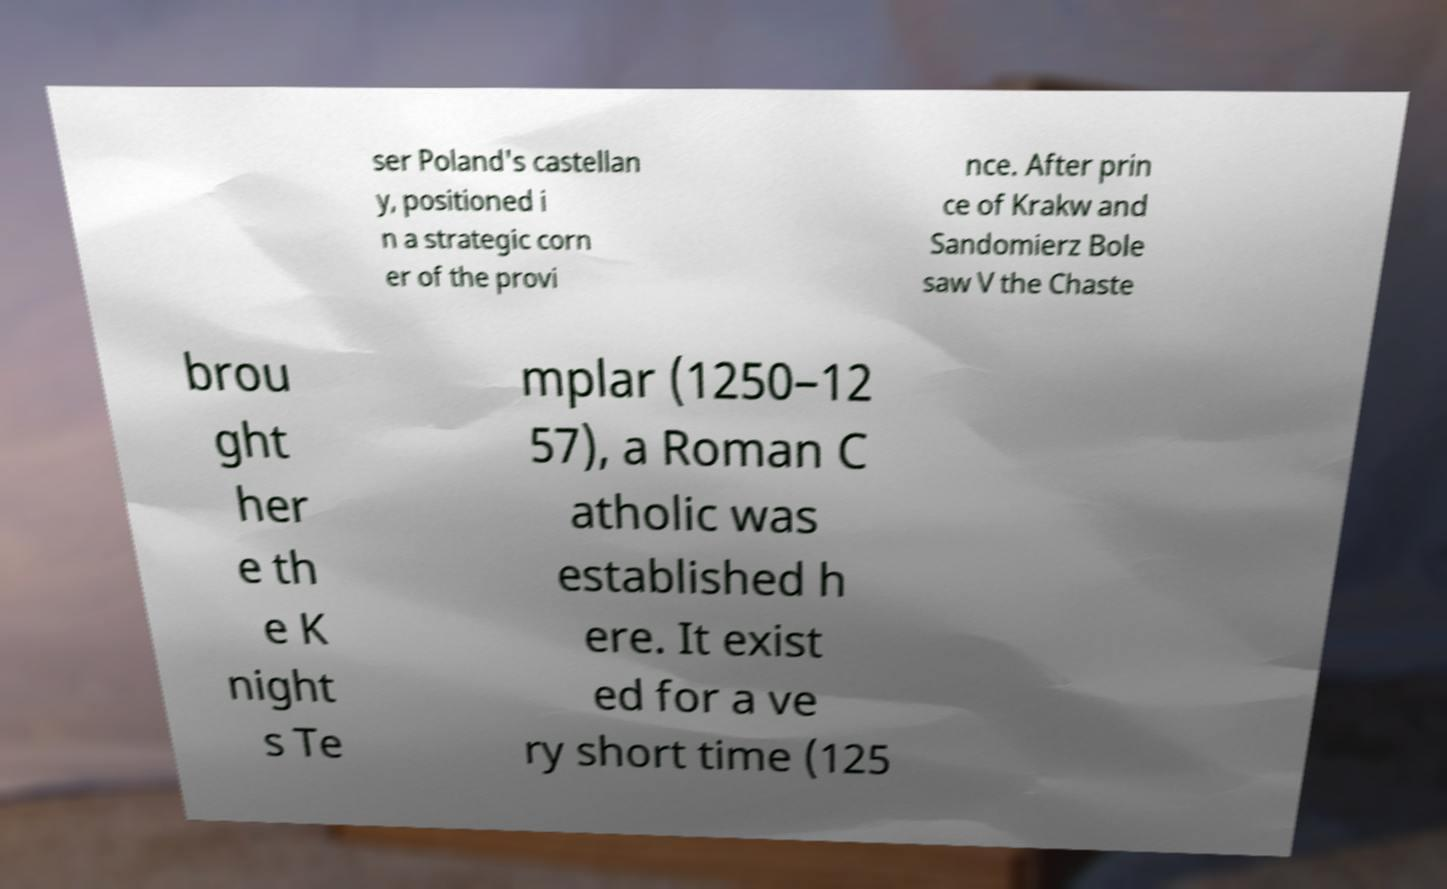Please read and relay the text visible in this image. What does it say? ser Poland's castellan y, positioned i n a strategic corn er of the provi nce. After prin ce of Krakw and Sandomierz Bole saw V the Chaste brou ght her e th e K night s Te mplar (1250–12 57), a Roman C atholic was established h ere. It exist ed for a ve ry short time (125 